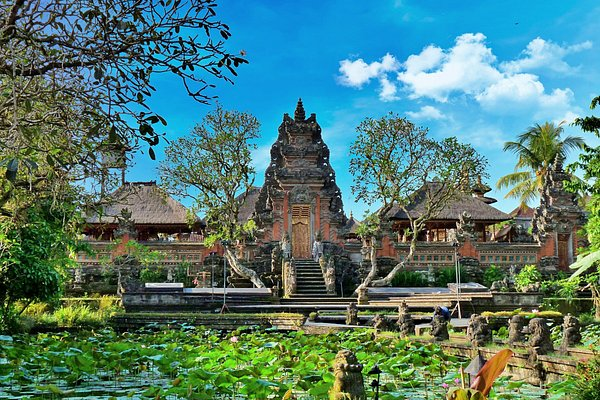If you had to describe the atmosphere of this place, what would you say? The atmosphere of this place is one of serene tranquility and timeless beauty. The stillness of the pond, the graceful architecture, and the lush greenery create a peaceful and reflective mood. It feels like a sanctuary, a place where one can escape the hustle and bustle of daily life and immerse oneself in nature and history. The gentle play of light and shadow, the subtle sounds of water and wildlife, and the vibrant colors all contribute to a sense of harmony and balance. Can you imagine what it would be like to visit this place at different times of the day? Visiting this place at different times of the day would offer unique and captivating experiences. In the early morning, the palace would be bathed in soft, golden light, the air fresh and cool, and the surroundings quiet and peaceful. Midday would bring vibrant colors and clearer reflections in the pond, capturing the essence of the natural beauty. As evening approaches, the setting sun would cast a warm glow over the buildings, and the atmosphere would grow more intimate and serene. Nighttime would transform the palace into a mystical, almost otherworldly scene, with the buildings illuminated by moonlight and the sounds of nocturnal creatures filling the air. 